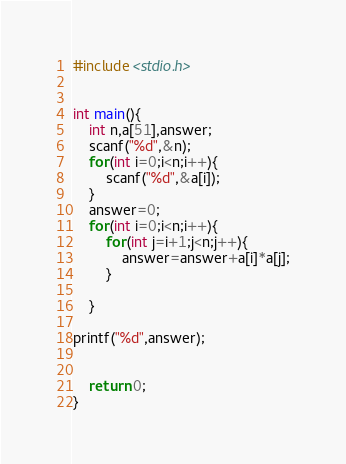Convert code to text. <code><loc_0><loc_0><loc_500><loc_500><_C_>#include <stdio.h>


int main(){
    int n,a[51],answer;
    scanf("%d",&n);
    for(int i=0;i<n;i++){
        scanf("%d",&a[i]);
    }
    answer=0;
    for(int i=0;i<n;i++){
        for(int j=i+1;j<n;j++){
            answer=answer+a[i]*a[j];
        }

    }

printf("%d",answer);


    return 0;
}</code> 